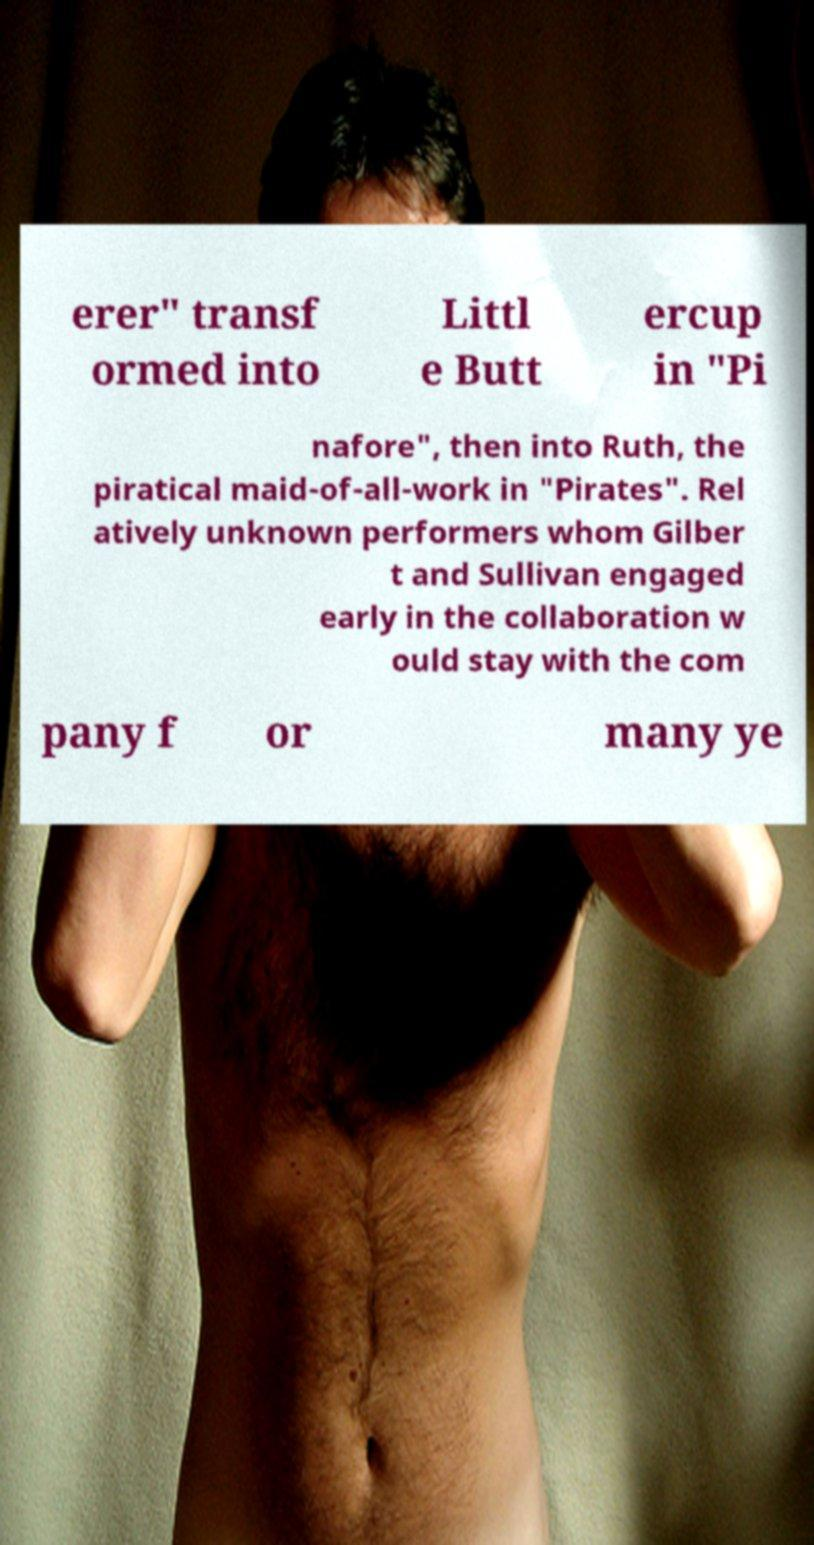What messages or text are displayed in this image? I need them in a readable, typed format. erer" transf ormed into Littl e Butt ercup in "Pi nafore", then into Ruth, the piratical maid-of-all-work in "Pirates". Rel atively unknown performers whom Gilber t and Sullivan engaged early in the collaboration w ould stay with the com pany f or many ye 